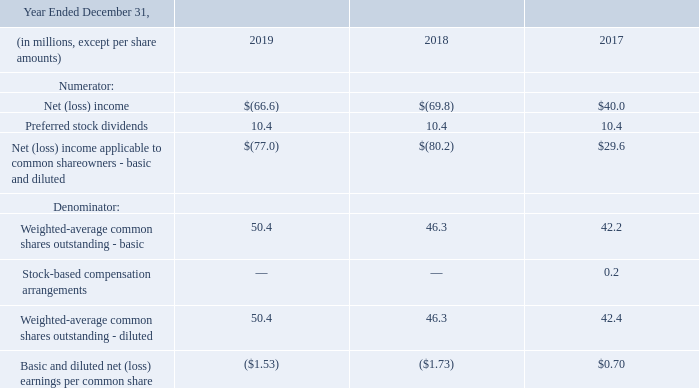5. Earnings Per Common Share
Basic earnings per common share ("EPS") is based upon the weighted-average number of common shares outstanding during the period.  Diluted EPS reflects the potential dilution that would occur upon issuance of common shares for awards under stock-based compensation plans, or conversion of preferred stock, but only to the extent that they are considered dilutive.
The following table shows the computation of basic and diluted EPS:
In conjunction with the acquisition of Hawaiian Telcom in the third quarter of 2018, the Company issued 7.7 million Common Shares as a part of the acquisition consideration. In addition, the Company granted 0.1 million time-based restricted stock units to certain Hawaiian Telcom employees under the Hawaiian Telcom 2010 Equity Incentive Plan
For the years ended December 31, 2019 and December 31, 2018, the Company had a net loss available to common shareholders and, as a result, all common stock equivalents were excluded from the computation of diluted EPS as their inclusion would have been anti-dilutive.  For the year ended December 31, 2017, awards under the Company’s stock-based compensation plans for common shares of 0.2 million, were excluded from the computation of diluted EPS as their inclusion would have been anti-dilutive.  For all periods presented, preferred stock convertible into 0.9 million common shares was excluded as it was anti-dilutive.
How many shares did the company issue as part of its acquisition consideration of Hawaiian Telcom?
Answer scale should be: million. 7.7. What was the value of the common shares excluded from the computation of diluted EPS for the year ended December 31, 2017?
Answer scale should be: million. 0.2. Which quarter of 2018 did the company grant shares to certain employees of Hawaiian Telcom? Third. What is the total Net (loss) income  between 2017 to 2019?
Answer scale should be: million. ($66.6)+($69.8)+$40.0
Answer: -96.4. What is the total basic and diluted net (loss) earnings per common share earned between 2017 to 2019? $(1.53)+$(1.73)+$0.70
Answer: -2.56. Which year has the largest weighted-average common shares outstanding - basic? 50.4 is the largest value
Answer: 2019. 